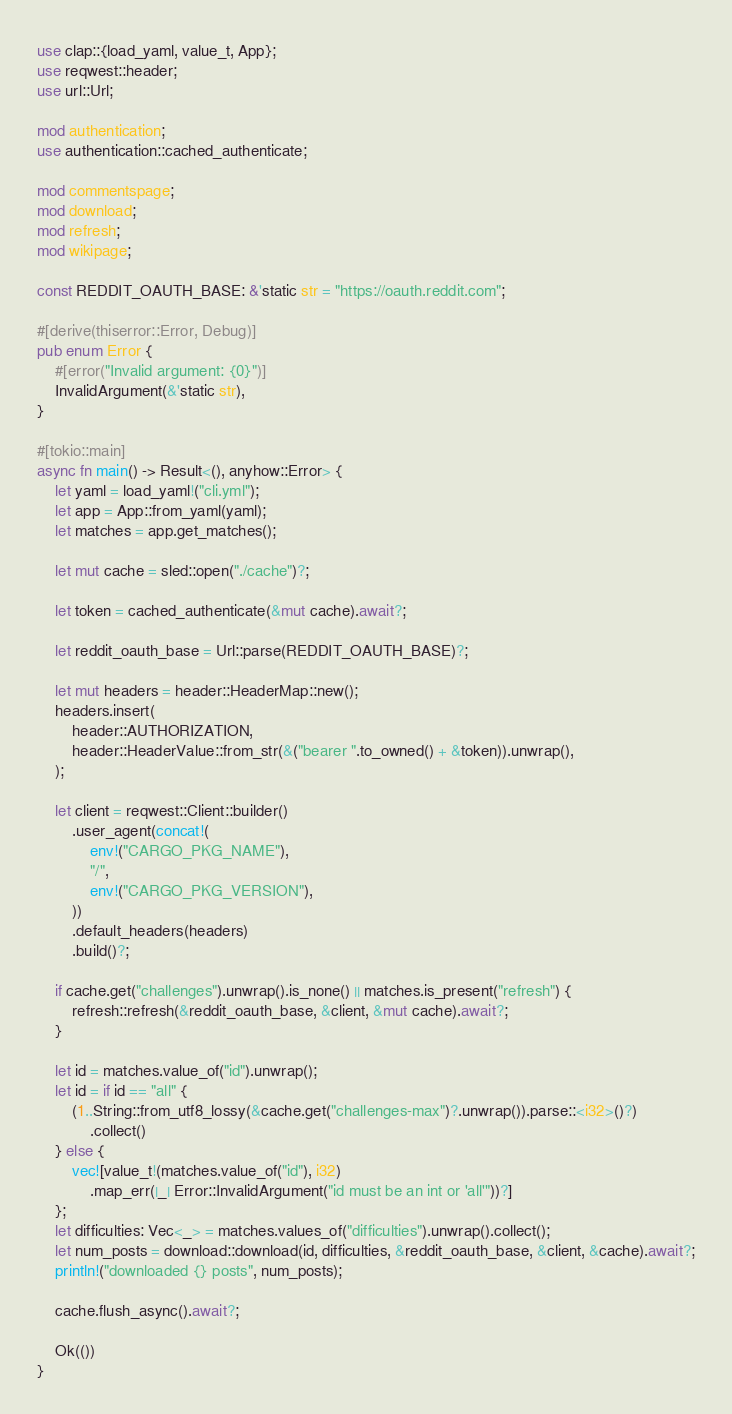<code> <loc_0><loc_0><loc_500><loc_500><_Rust_>use clap::{load_yaml, value_t, App};
use reqwest::header;
use url::Url;

mod authentication;
use authentication::cached_authenticate;

mod commentspage;
mod download;
mod refresh;
mod wikipage;

const REDDIT_OAUTH_BASE: &'static str = "https://oauth.reddit.com";

#[derive(thiserror::Error, Debug)]
pub enum Error {
    #[error("Invalid argument: {0}")]
    InvalidArgument(&'static str),
}

#[tokio::main]
async fn main() -> Result<(), anyhow::Error> {
    let yaml = load_yaml!("cli.yml");
    let app = App::from_yaml(yaml);
    let matches = app.get_matches();

    let mut cache = sled::open("./cache")?;

    let token = cached_authenticate(&mut cache).await?;

    let reddit_oauth_base = Url::parse(REDDIT_OAUTH_BASE)?;

    let mut headers = header::HeaderMap::new();
    headers.insert(
        header::AUTHORIZATION,
        header::HeaderValue::from_str(&("bearer ".to_owned() + &token)).unwrap(),
    );

    let client = reqwest::Client::builder()
        .user_agent(concat!(
            env!("CARGO_PKG_NAME"),
            "/",
            env!("CARGO_PKG_VERSION"),
        ))
        .default_headers(headers)
        .build()?;

    if cache.get("challenges").unwrap().is_none() || matches.is_present("refresh") {
        refresh::refresh(&reddit_oauth_base, &client, &mut cache).await?;
    }

    let id = matches.value_of("id").unwrap();
    let id = if id == "all" {
        (1..String::from_utf8_lossy(&cache.get("challenges-max")?.unwrap()).parse::<i32>()?)
            .collect()
    } else {
        vec![value_t!(matches.value_of("id"), i32)
            .map_err(|_| Error::InvalidArgument("id must be an int or 'all'"))?]
    };
    let difficulties: Vec<_> = matches.values_of("difficulties").unwrap().collect();
    let num_posts = download::download(id, difficulties, &reddit_oauth_base, &client, &cache).await?;
    println!("downloaded {} posts", num_posts);

    cache.flush_async().await?;

    Ok(())
}
</code> 